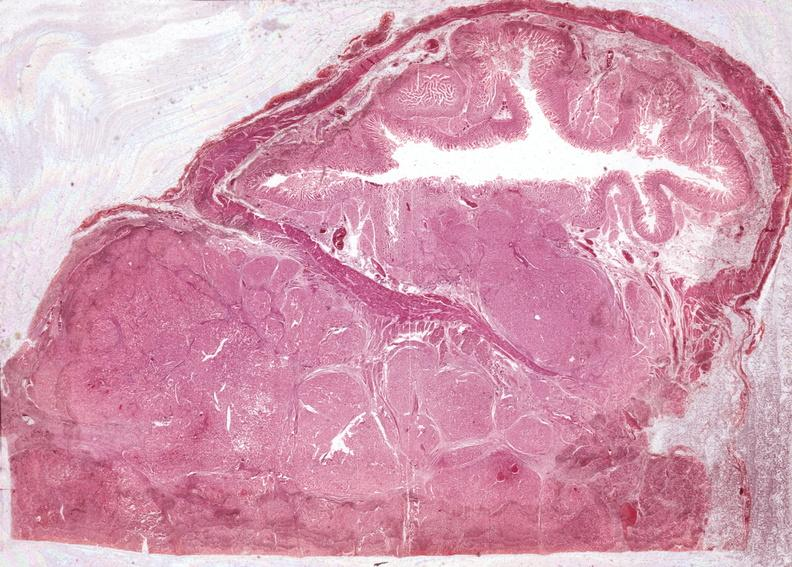where is this?
Answer the question using a single word or phrase. Pancreas 